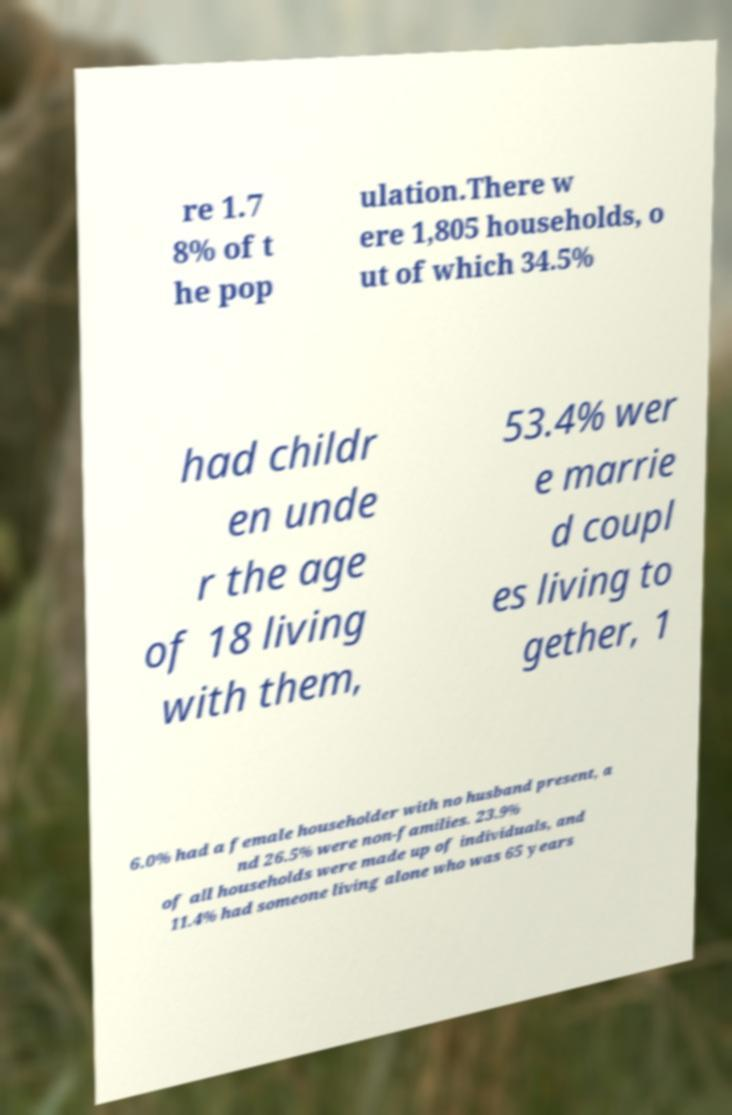There's text embedded in this image that I need extracted. Can you transcribe it verbatim? re 1.7 8% of t he pop ulation.There w ere 1,805 households, o ut of which 34.5% had childr en unde r the age of 18 living with them, 53.4% wer e marrie d coupl es living to gether, 1 6.0% had a female householder with no husband present, a nd 26.5% were non-families. 23.9% of all households were made up of individuals, and 11.4% had someone living alone who was 65 years 